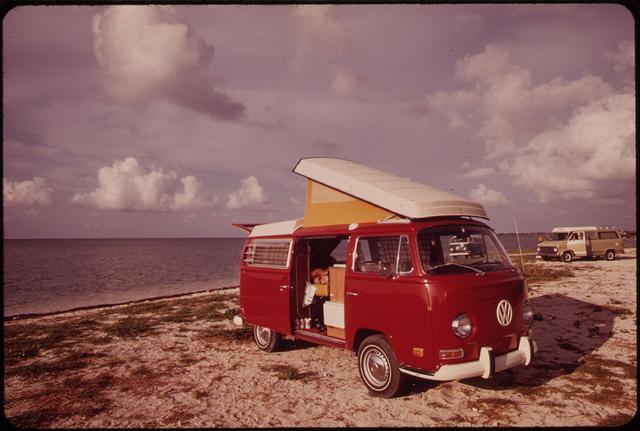How many trucks are there?
Give a very brief answer. 2. How many chairs are at the table?
Give a very brief answer. 0. 